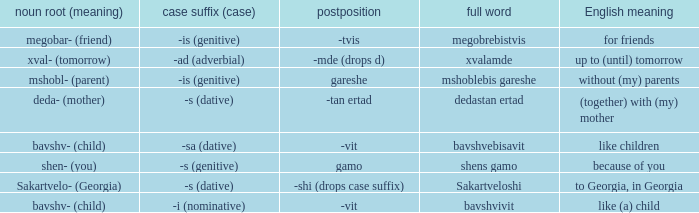What is Case Suffix (Case), when Postposition is "-mde (drops d)"? -ad (adverbial). 